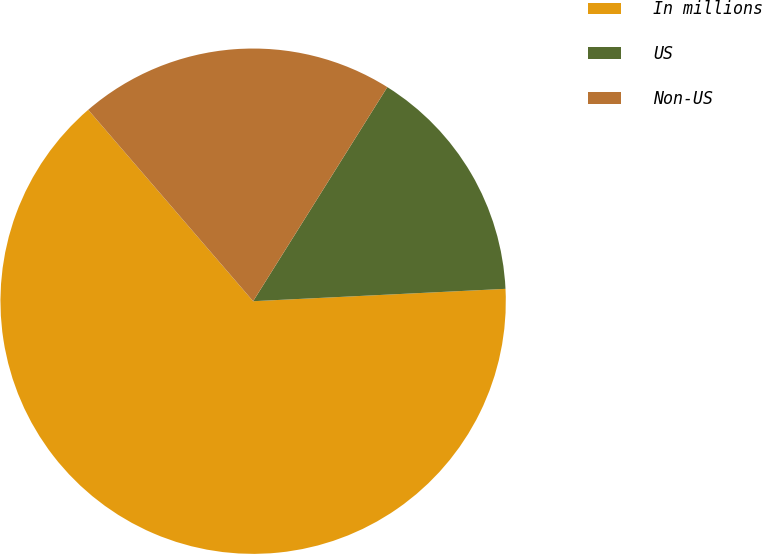Convert chart. <chart><loc_0><loc_0><loc_500><loc_500><pie_chart><fcel>In millions<fcel>US<fcel>Non-US<nl><fcel>64.46%<fcel>15.31%<fcel>20.23%<nl></chart> 